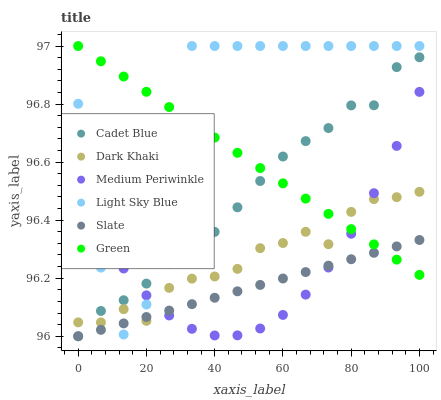Does Slate have the minimum area under the curve?
Answer yes or no. Yes. Does Light Sky Blue have the maximum area under the curve?
Answer yes or no. Yes. Does Medium Periwinkle have the minimum area under the curve?
Answer yes or no. No. Does Medium Periwinkle have the maximum area under the curve?
Answer yes or no. No. Is Slate the smoothest?
Answer yes or no. Yes. Is Light Sky Blue the roughest?
Answer yes or no. Yes. Is Medium Periwinkle the smoothest?
Answer yes or no. No. Is Medium Periwinkle the roughest?
Answer yes or no. No. Does Cadet Blue have the lowest value?
Answer yes or no. Yes. Does Medium Periwinkle have the lowest value?
Answer yes or no. No. Does Green have the highest value?
Answer yes or no. Yes. Does Medium Periwinkle have the highest value?
Answer yes or no. No. Does Slate intersect Cadet Blue?
Answer yes or no. Yes. Is Slate less than Cadet Blue?
Answer yes or no. No. Is Slate greater than Cadet Blue?
Answer yes or no. No. 